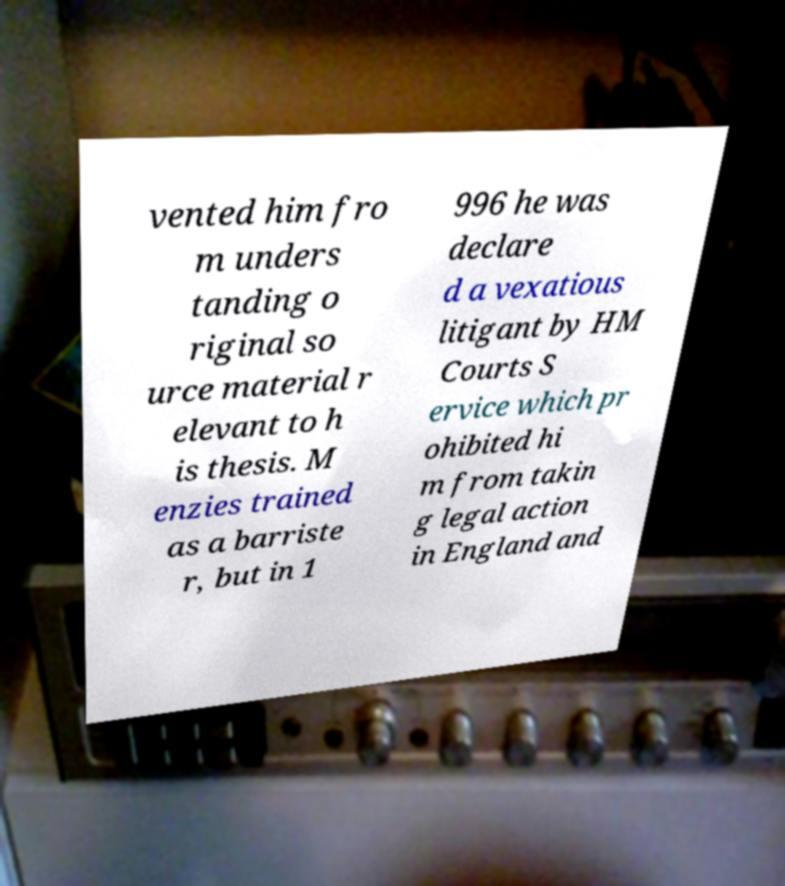What messages or text are displayed in this image? I need them in a readable, typed format. vented him fro m unders tanding o riginal so urce material r elevant to h is thesis. M enzies trained as a barriste r, but in 1 996 he was declare d a vexatious litigant by HM Courts S ervice which pr ohibited hi m from takin g legal action in England and 